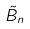Convert formula to latex. <formula><loc_0><loc_0><loc_500><loc_500>\tilde { B } _ { n }</formula> 